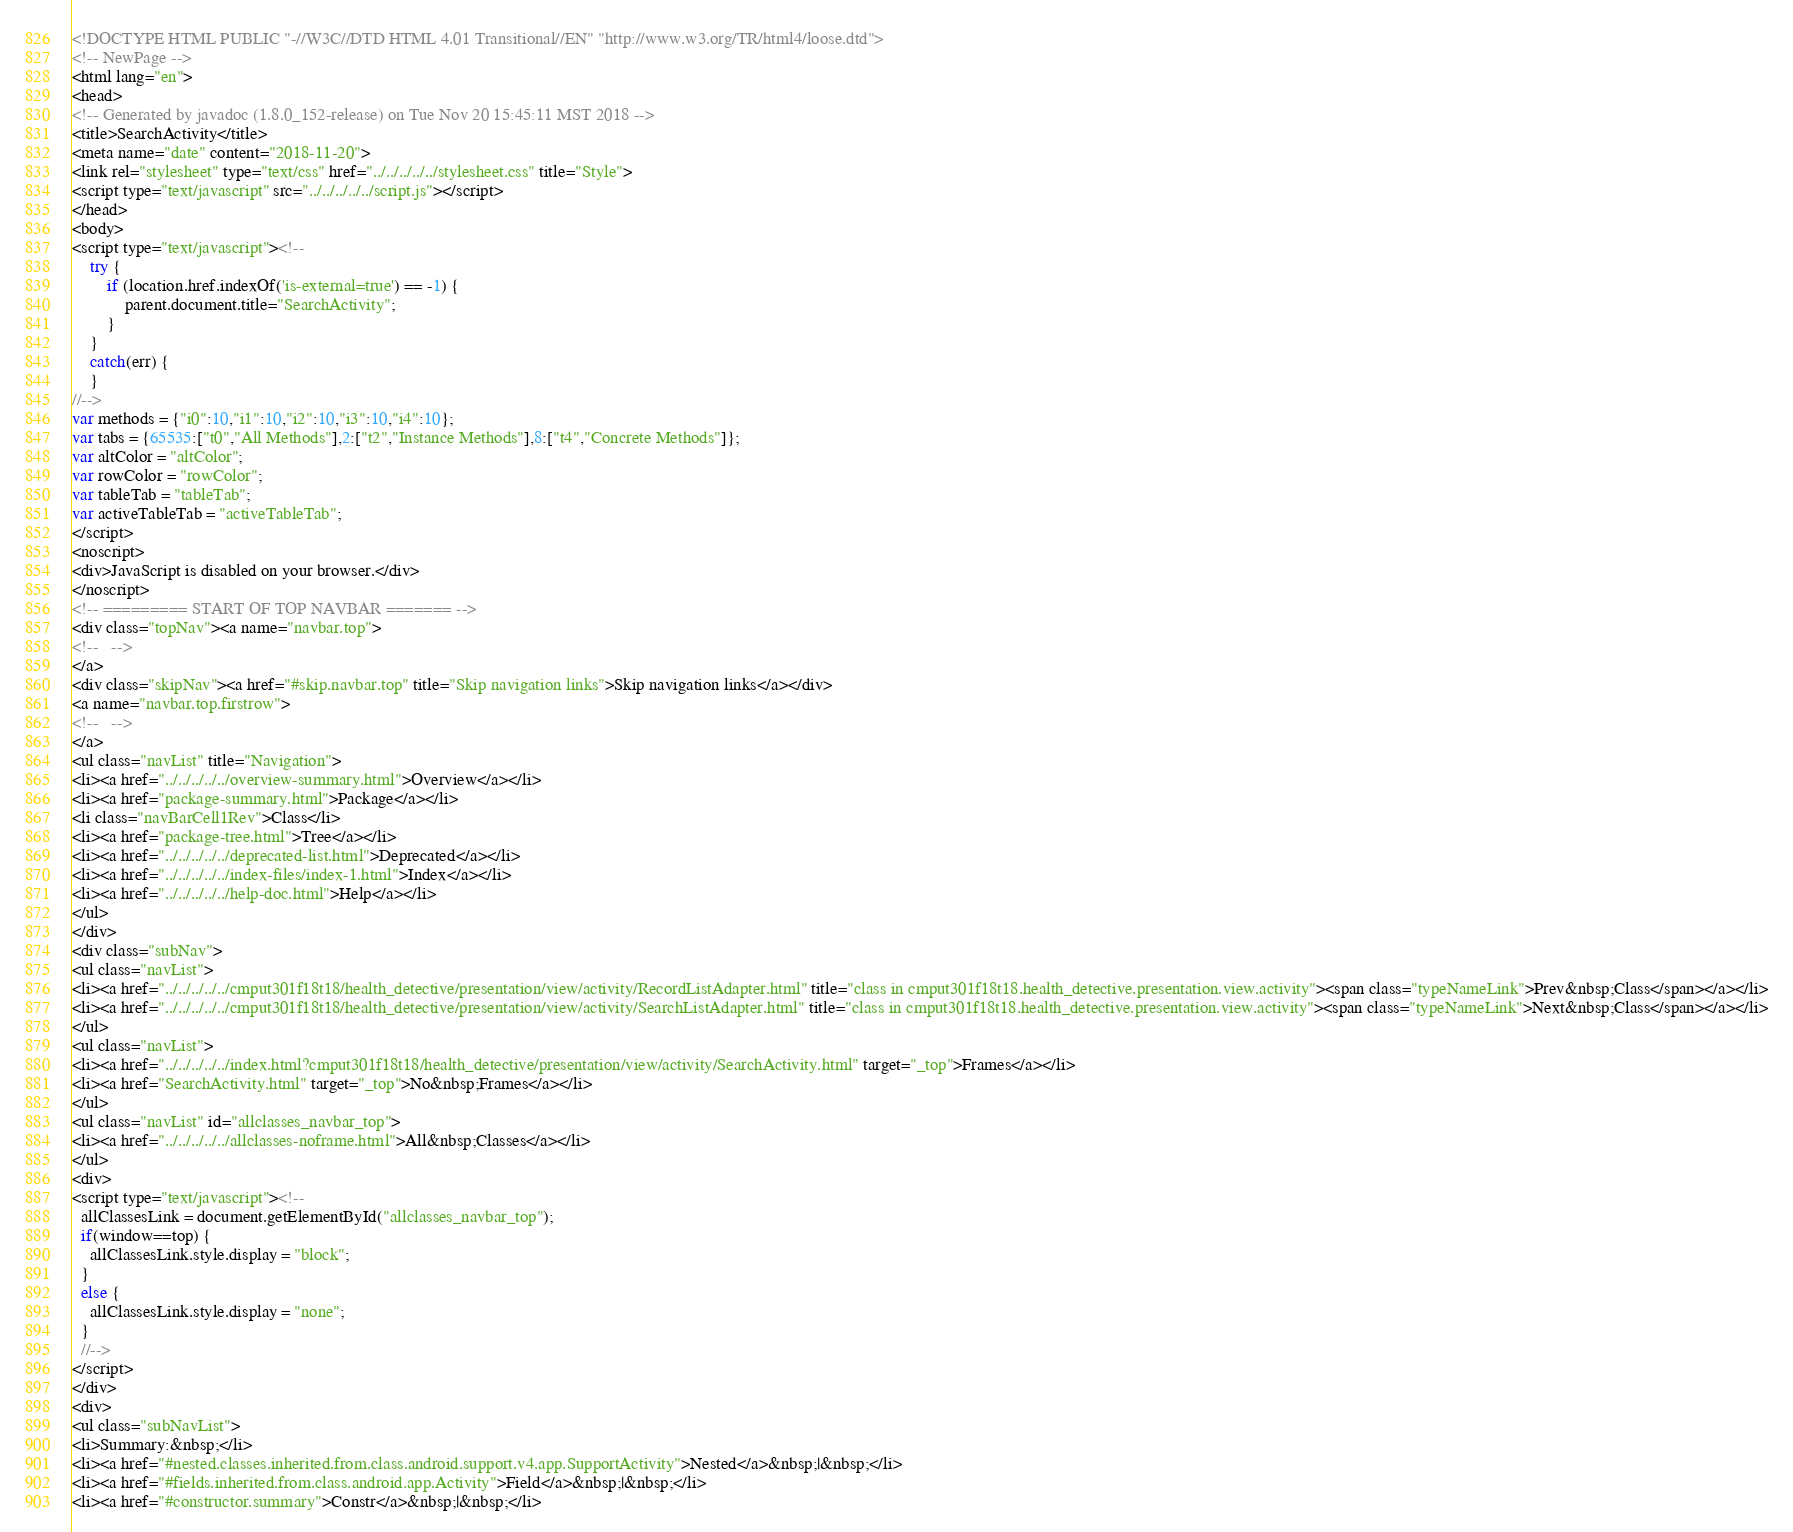<code> <loc_0><loc_0><loc_500><loc_500><_HTML_><!DOCTYPE HTML PUBLIC "-//W3C//DTD HTML 4.01 Transitional//EN" "http://www.w3.org/TR/html4/loose.dtd">
<!-- NewPage -->
<html lang="en">
<head>
<!-- Generated by javadoc (1.8.0_152-release) on Tue Nov 20 15:45:11 MST 2018 -->
<title>SearchActivity</title>
<meta name="date" content="2018-11-20">
<link rel="stylesheet" type="text/css" href="../../../../../stylesheet.css" title="Style">
<script type="text/javascript" src="../../../../../script.js"></script>
</head>
<body>
<script type="text/javascript"><!--
    try {
        if (location.href.indexOf('is-external=true') == -1) {
            parent.document.title="SearchActivity";
        }
    }
    catch(err) {
    }
//-->
var methods = {"i0":10,"i1":10,"i2":10,"i3":10,"i4":10};
var tabs = {65535:["t0","All Methods"],2:["t2","Instance Methods"],8:["t4","Concrete Methods"]};
var altColor = "altColor";
var rowColor = "rowColor";
var tableTab = "tableTab";
var activeTableTab = "activeTableTab";
</script>
<noscript>
<div>JavaScript is disabled on your browser.</div>
</noscript>
<!-- ========= START OF TOP NAVBAR ======= -->
<div class="topNav"><a name="navbar.top">
<!--   -->
</a>
<div class="skipNav"><a href="#skip.navbar.top" title="Skip navigation links">Skip navigation links</a></div>
<a name="navbar.top.firstrow">
<!--   -->
</a>
<ul class="navList" title="Navigation">
<li><a href="../../../../../overview-summary.html">Overview</a></li>
<li><a href="package-summary.html">Package</a></li>
<li class="navBarCell1Rev">Class</li>
<li><a href="package-tree.html">Tree</a></li>
<li><a href="../../../../../deprecated-list.html">Deprecated</a></li>
<li><a href="../../../../../index-files/index-1.html">Index</a></li>
<li><a href="../../../../../help-doc.html">Help</a></li>
</ul>
</div>
<div class="subNav">
<ul class="navList">
<li><a href="../../../../../cmput301f18t18/health_detective/presentation/view/activity/RecordListAdapter.html" title="class in cmput301f18t18.health_detective.presentation.view.activity"><span class="typeNameLink">Prev&nbsp;Class</span></a></li>
<li><a href="../../../../../cmput301f18t18/health_detective/presentation/view/activity/SearchListAdapter.html" title="class in cmput301f18t18.health_detective.presentation.view.activity"><span class="typeNameLink">Next&nbsp;Class</span></a></li>
</ul>
<ul class="navList">
<li><a href="../../../../../index.html?cmput301f18t18/health_detective/presentation/view/activity/SearchActivity.html" target="_top">Frames</a></li>
<li><a href="SearchActivity.html" target="_top">No&nbsp;Frames</a></li>
</ul>
<ul class="navList" id="allclasses_navbar_top">
<li><a href="../../../../../allclasses-noframe.html">All&nbsp;Classes</a></li>
</ul>
<div>
<script type="text/javascript"><!--
  allClassesLink = document.getElementById("allclasses_navbar_top");
  if(window==top) {
    allClassesLink.style.display = "block";
  }
  else {
    allClassesLink.style.display = "none";
  }
  //-->
</script>
</div>
<div>
<ul class="subNavList">
<li>Summary:&nbsp;</li>
<li><a href="#nested.classes.inherited.from.class.android.support.v4.app.SupportActivity">Nested</a>&nbsp;|&nbsp;</li>
<li><a href="#fields.inherited.from.class.android.app.Activity">Field</a>&nbsp;|&nbsp;</li>
<li><a href="#constructor.summary">Constr</a>&nbsp;|&nbsp;</li></code> 